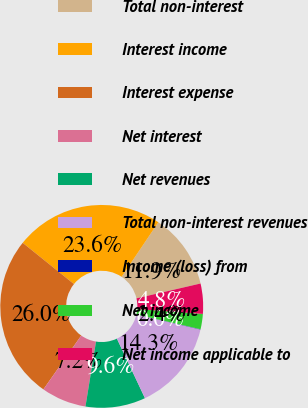<chart> <loc_0><loc_0><loc_500><loc_500><pie_chart><fcel>Total non-interest<fcel>Interest income<fcel>Interest expense<fcel>Net interest<fcel>Net revenues<fcel>Total non-interest revenues<fcel>Income (loss) from<fcel>Net income<fcel>Net income applicable to<nl><fcel>11.95%<fcel>23.65%<fcel>26.03%<fcel>7.19%<fcel>9.57%<fcel>14.33%<fcel>0.05%<fcel>2.43%<fcel>4.81%<nl></chart> 